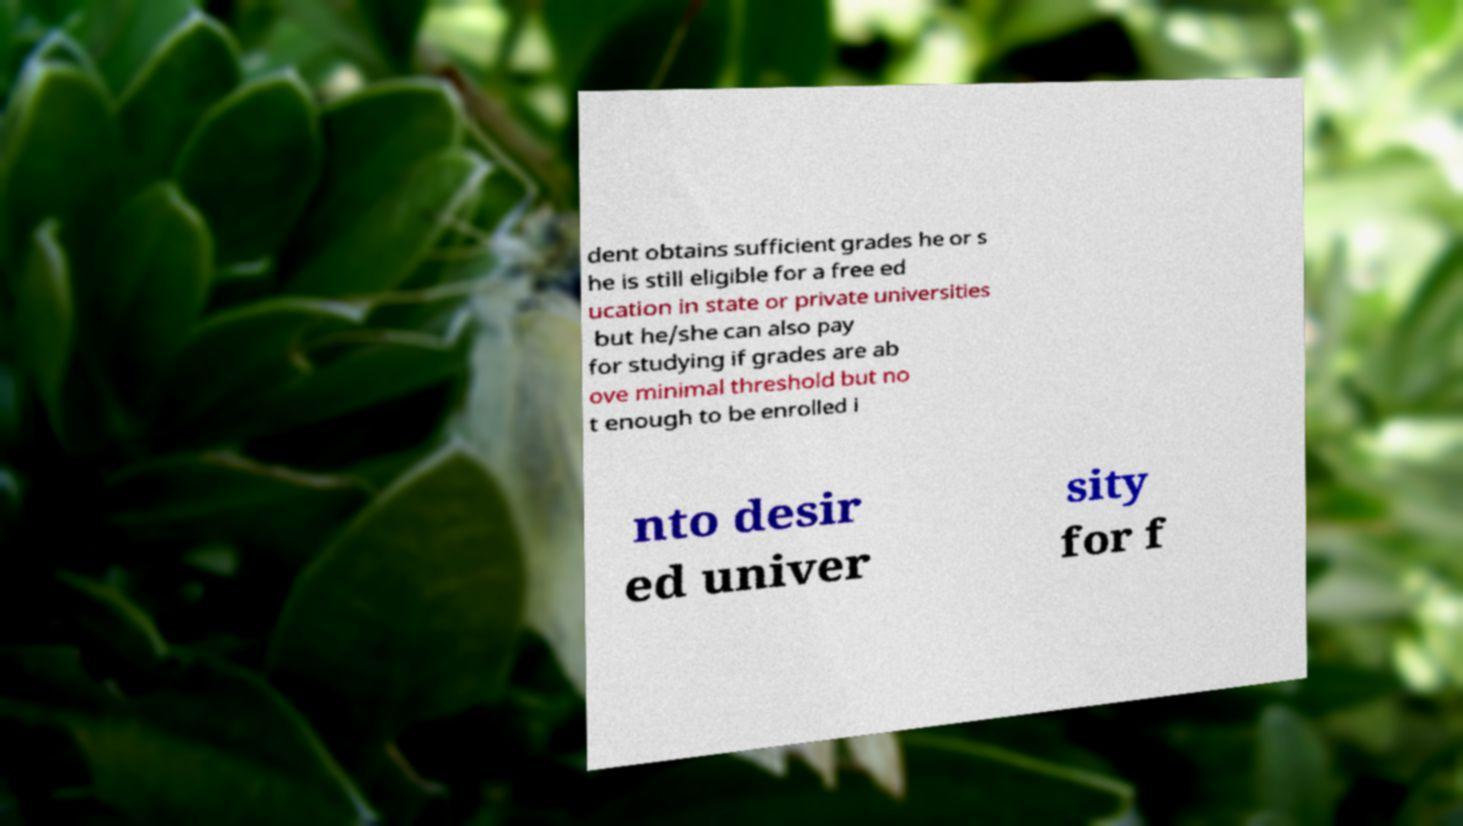For documentation purposes, I need the text within this image transcribed. Could you provide that? dent obtains sufficient grades he or s he is still eligible for a free ed ucation in state or private universities but he/she can also pay for studying if grades are ab ove minimal threshold but no t enough to be enrolled i nto desir ed univer sity for f 